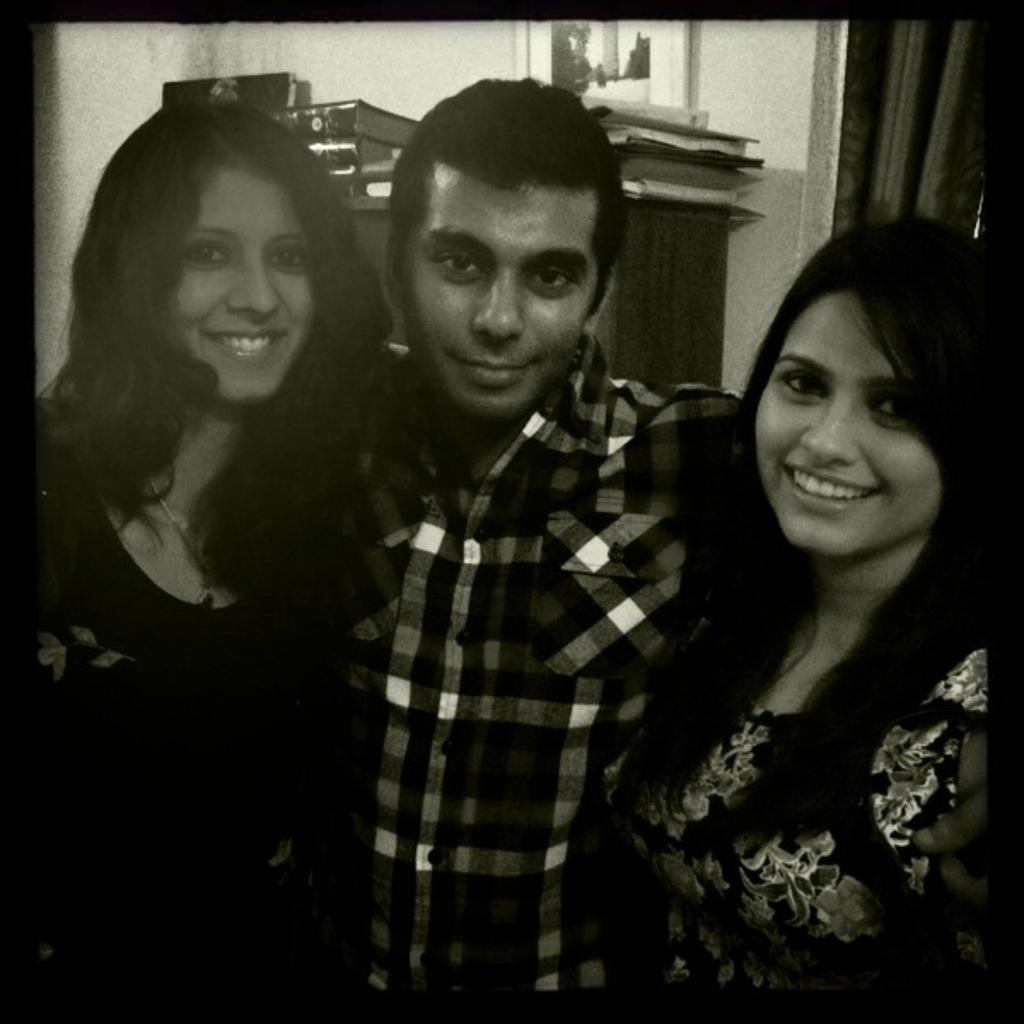In one or two sentences, can you explain what this image depicts? In this picture I can see there are three persons standing here, they are smiling and in the backdrop there is a wooden shelf and there are some books placed on the wooden shelf and in the backdrop I can see there is a curtain and a wall with a photo frame. 